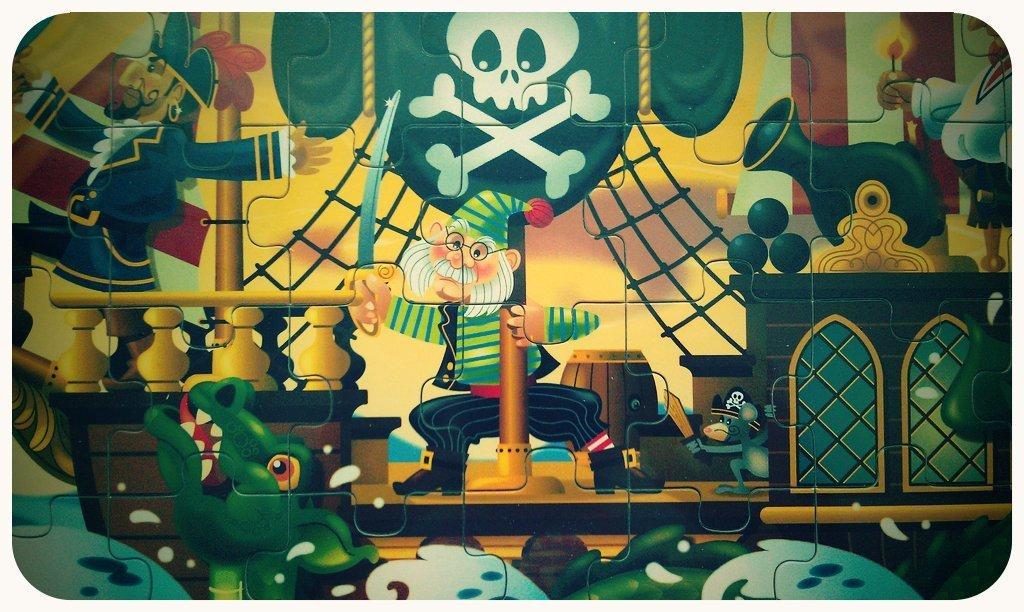How would you summarize this image in a sentence or two? In the picture I can see puzzle game. On this puzzle cards I can see picture of cartoon characters and some other objects. 